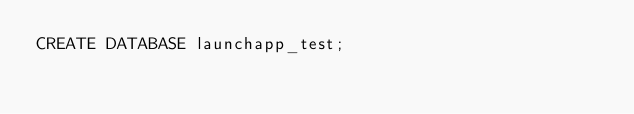Convert code to text. <code><loc_0><loc_0><loc_500><loc_500><_SQL_>CREATE DATABASE launchapp_test;</code> 